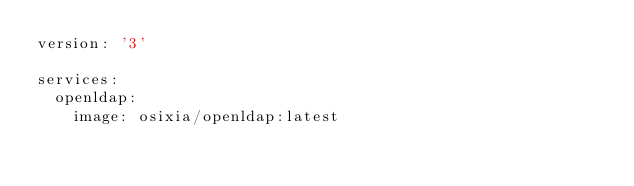Convert code to text. <code><loc_0><loc_0><loc_500><loc_500><_YAML_>version: '3'

services:
  openldap:
    image: osixia/openldap:latest</code> 